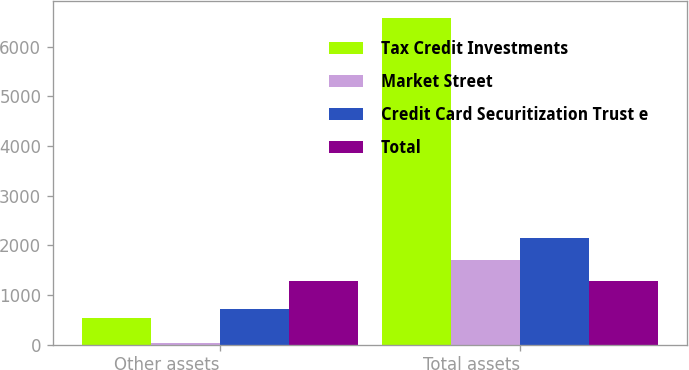<chart> <loc_0><loc_0><loc_500><loc_500><stacked_bar_chart><ecel><fcel>Other assets<fcel>Total assets<nl><fcel>Tax Credit Investments<fcel>536<fcel>6583<nl><fcel>Market Street<fcel>31<fcel>1699<nl><fcel>Credit Card Securitization Trust e<fcel>714<fcel>2153<nl><fcel>Total<fcel>1281<fcel>1281<nl></chart> 